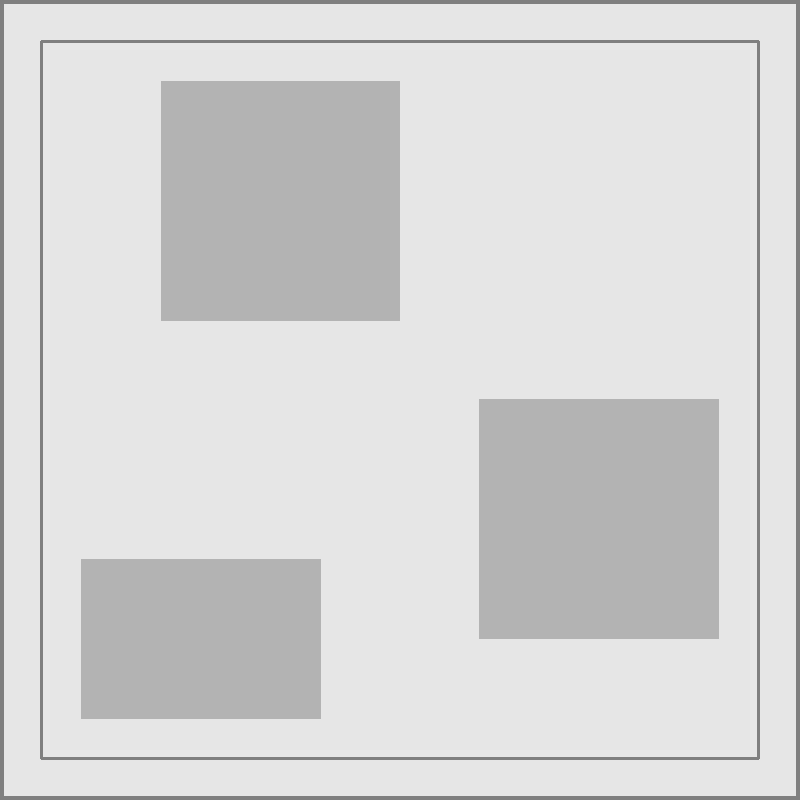As a UN Human Rights official, you're analyzing aerial photos of industrial areas to detect signs of forced labor. Based on the image provided, which feature is most indicative of potential forced labor practices? To answer this question, let's analyze the key elements in the aerial photo:

1. Buildings: The image shows three large structures, typical of an industrial area. While the presence of buildings alone doesn't indicate forced labor, their layout and size can be relevant.

2. Fences: There are two layers of fencing around the perimeter of the industrial area. This high level of security could be a red flag, as it may indicate attempts to control movement in and out of the facility.

3. Crowd: A dense concentration of dots representing people is visible in one corner of the compound. This unusual clustering of individuals in an industrial setting is particularly noteworthy.

Analyzing these elements:

- Buildings are common in industrial areas and don't necessarily indicate forced labor.
- Double fencing is suspicious but could be explained by legitimate security concerns.
- The dense crowd in a confined area of an industrial compound is highly unusual and concerning.

In the context of forced labor, the crowd is the most alarming feature. Large groups of people confined in industrial settings, especially in areas separate from the main buildings, can indicate:

- Restricted movement
- Overcrowded living conditions
- Potential holding areas for workers

These are all potential indicators of forced labor practices. While other elements contribute to the overall assessment, the unusual crowd pattern is the strongest individual indicator in this image.
Answer: The dense crowd in a confined area 